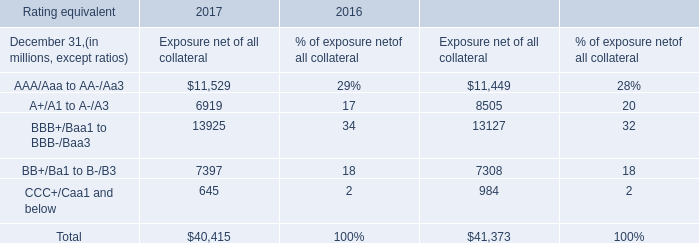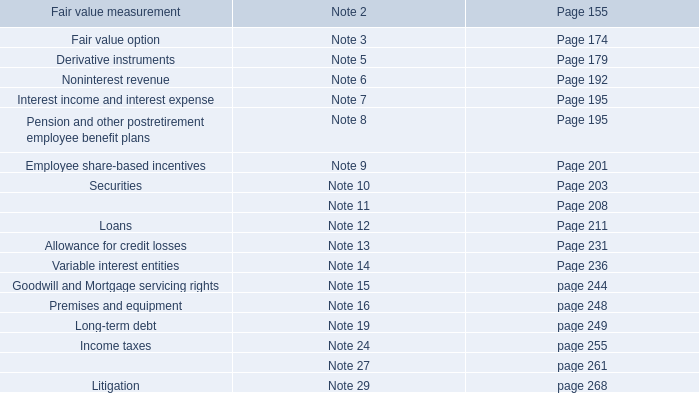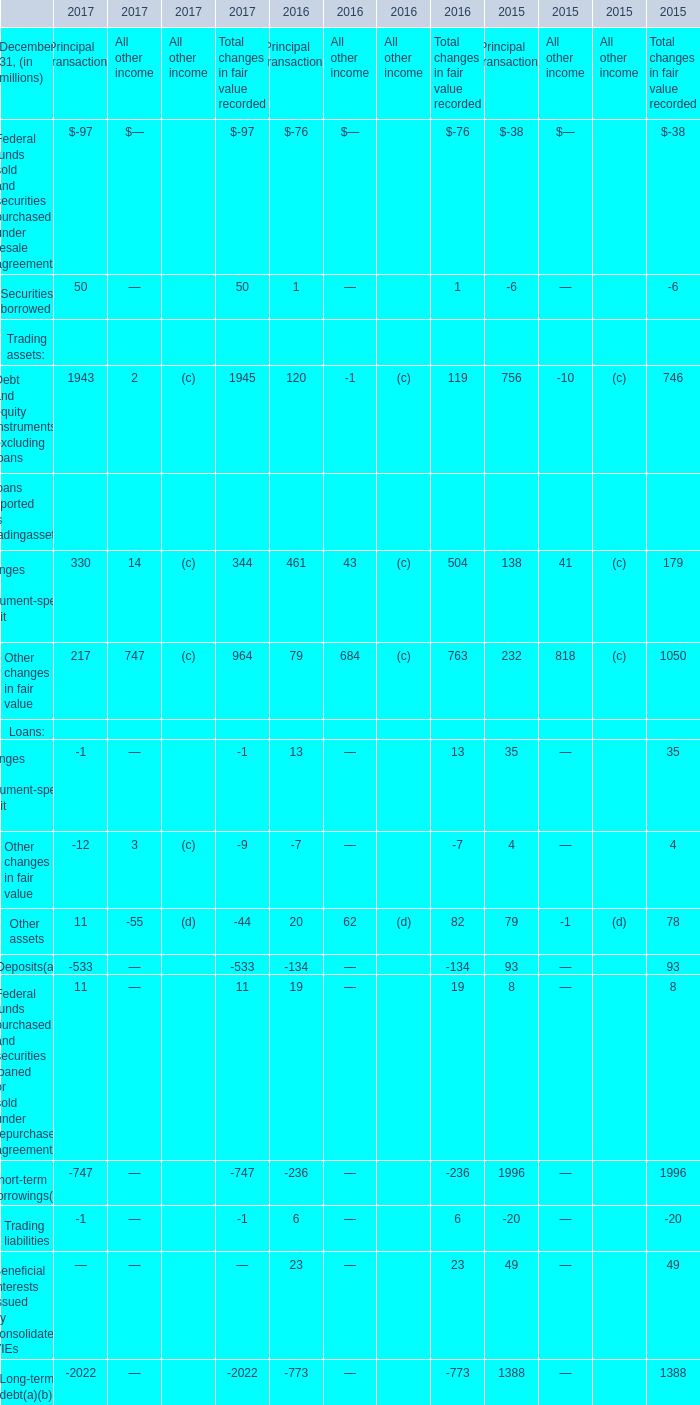In what year is the Long-term debt for Principal transactions greater than 1000 million? 
Answer: 2015. 